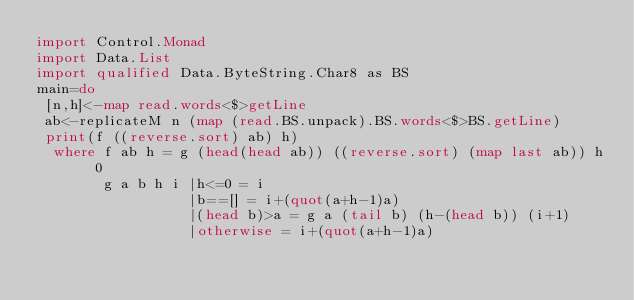Convert code to text. <code><loc_0><loc_0><loc_500><loc_500><_Haskell_>import Control.Monad
import Data.List
import qualified Data.ByteString.Char8 as BS
main=do
 [n,h]<-map read.words<$>getLine
 ab<-replicateM n (map (read.BS.unpack).BS.words<$>BS.getLine)
 print(f ((reverse.sort) ab) h)
  where f ab h = g (head(head ab)) ((reverse.sort) (map last ab)) h 0
        g a b h i |h<=0 = i
                  |b==[] = i+(quot(a+h-1)a)
                  |(head b)>a = g a (tail b) (h-(head b)) (i+1)
                  |otherwise = i+(quot(a+h-1)a)</code> 